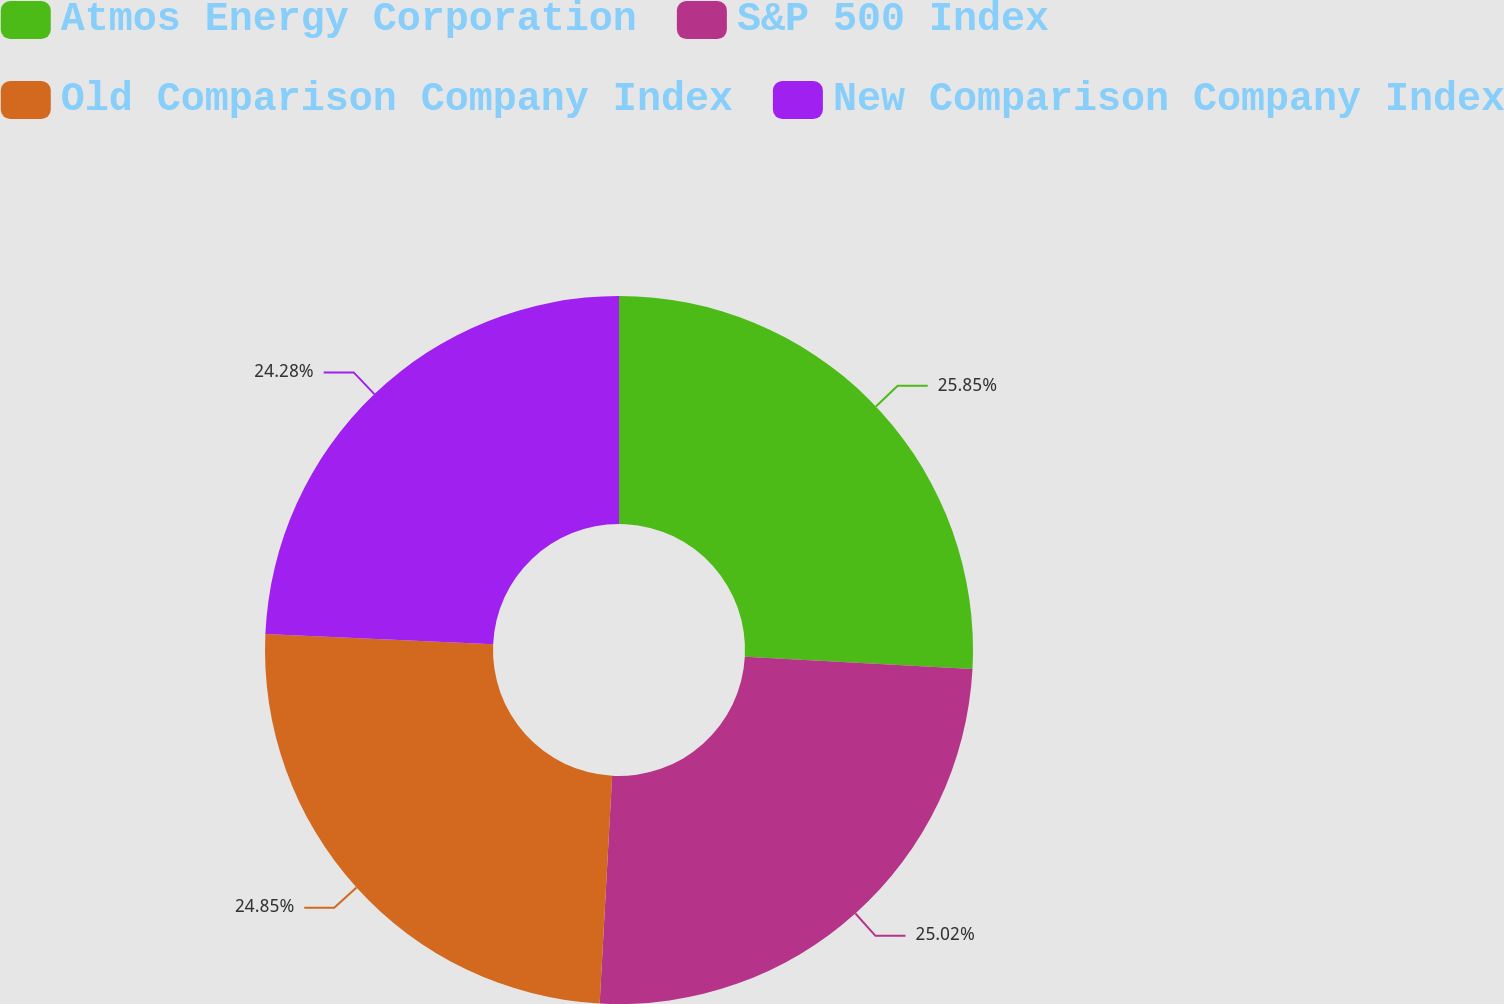Convert chart. <chart><loc_0><loc_0><loc_500><loc_500><pie_chart><fcel>Atmos Energy Corporation<fcel>S&P 500 Index<fcel>Old Comparison Company Index<fcel>New Comparison Company Index<nl><fcel>25.85%<fcel>25.02%<fcel>24.85%<fcel>24.28%<nl></chart> 